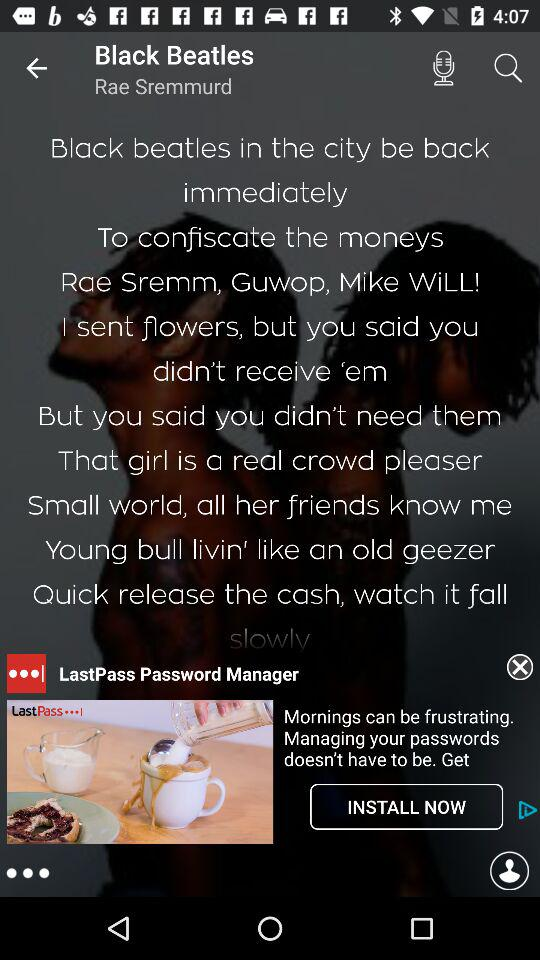Who is the singer of the song "Black Beatles"? The singer of the song "Black Beatles" is Rae Sremmurd. 